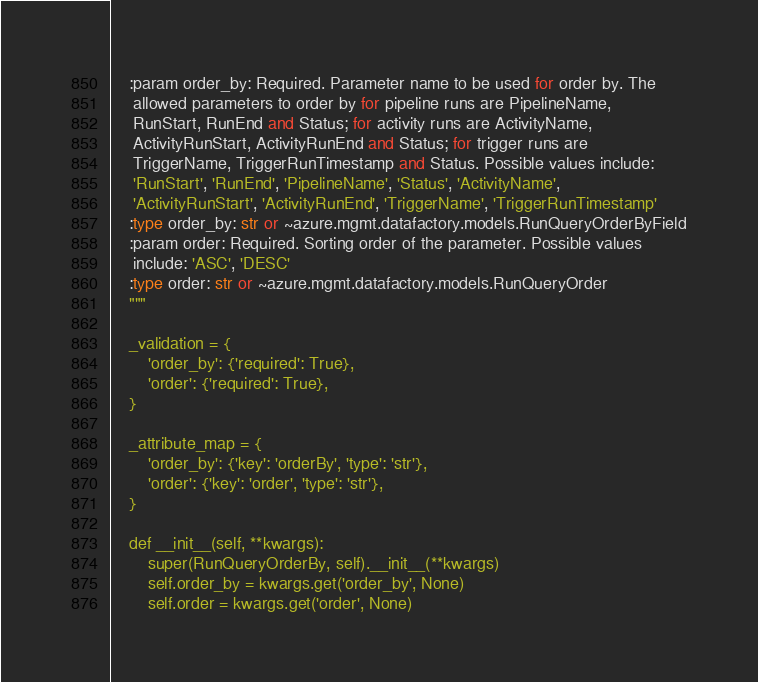Convert code to text. <code><loc_0><loc_0><loc_500><loc_500><_Python_>    :param order_by: Required. Parameter name to be used for order by. The
     allowed parameters to order by for pipeline runs are PipelineName,
     RunStart, RunEnd and Status; for activity runs are ActivityName,
     ActivityRunStart, ActivityRunEnd and Status; for trigger runs are
     TriggerName, TriggerRunTimestamp and Status. Possible values include:
     'RunStart', 'RunEnd', 'PipelineName', 'Status', 'ActivityName',
     'ActivityRunStart', 'ActivityRunEnd', 'TriggerName', 'TriggerRunTimestamp'
    :type order_by: str or ~azure.mgmt.datafactory.models.RunQueryOrderByField
    :param order: Required. Sorting order of the parameter. Possible values
     include: 'ASC', 'DESC'
    :type order: str or ~azure.mgmt.datafactory.models.RunQueryOrder
    """

    _validation = {
        'order_by': {'required': True},
        'order': {'required': True},
    }

    _attribute_map = {
        'order_by': {'key': 'orderBy', 'type': 'str'},
        'order': {'key': 'order', 'type': 'str'},
    }

    def __init__(self, **kwargs):
        super(RunQueryOrderBy, self).__init__(**kwargs)
        self.order_by = kwargs.get('order_by', None)
        self.order = kwargs.get('order', None)
</code> 